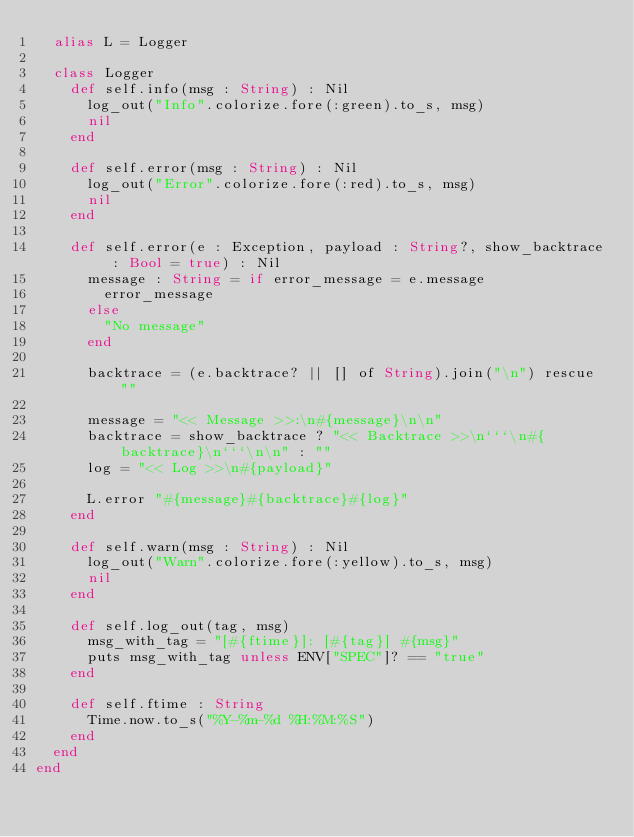Convert code to text. <code><loc_0><loc_0><loc_500><loc_500><_Crystal_>  alias L = Logger

  class Logger
    def self.info(msg : String) : Nil
      log_out("Info".colorize.fore(:green).to_s, msg)
      nil
    end

    def self.error(msg : String) : Nil
      log_out("Error".colorize.fore(:red).to_s, msg)
      nil
    end

    def self.error(e : Exception, payload : String?, show_backtrace : Bool = true) : Nil
      message : String = if error_message = e.message
        error_message
      else
        "No message"
      end

      backtrace = (e.backtrace? || [] of String).join("\n") rescue ""

      message = "<< Message >>:\n#{message}\n\n"
      backtrace = show_backtrace ? "<< Backtrace >>\n```\n#{backtrace}\n```\n\n" : ""
      log = "<< Log >>\n#{payload}"

      L.error "#{message}#{backtrace}#{log}"
    end

    def self.warn(msg : String) : Nil
      log_out("Warn".colorize.fore(:yellow).to_s, msg)
      nil
    end

    def self.log_out(tag, msg)
      msg_with_tag = "[#{ftime}]: [#{tag}] #{msg}"
      puts msg_with_tag unless ENV["SPEC"]? == "true"
    end

    def self.ftime : String
      Time.now.to_s("%Y-%m-%d %H:%M:%S")
    end
  end
end
</code> 